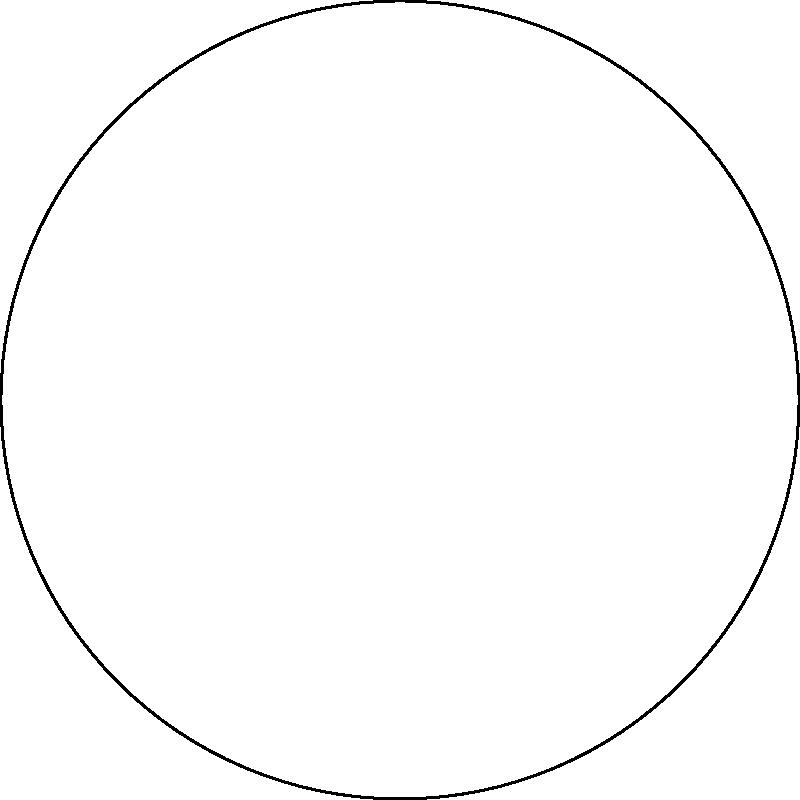You're designing a circular logo with six symmetrical elements. Using polar coordinates, at what angle intervals should you place these elements to ensure equal spacing around the circle? To create a symmetrical logo with six equally spaced elements, we need to follow these steps:

1. Recall that a full circle contains 360°.

2. To divide the circle into six equal parts, we need to divide 360° by 6:

   $$\frac{360°}{6} = 60°$$

3. This means that each element should be placed at 60° intervals around the circle.

4. Starting from 0°, the angles for each element would be:
   - 0°
   - 60°
   - 120°
   - 180°
   - 240°
   - 300°

5. In polar coordinates, these angles would be represented as:
   $$0, \frac{\pi}{3}, \frac{2\pi}{3}, \pi, \frac{4\pi}{3}, \frac{5\pi}{3}$$ radians

6. By placing elements at these angles, you ensure equal spacing and symmetry in your circular logo design.
Answer: 60° 